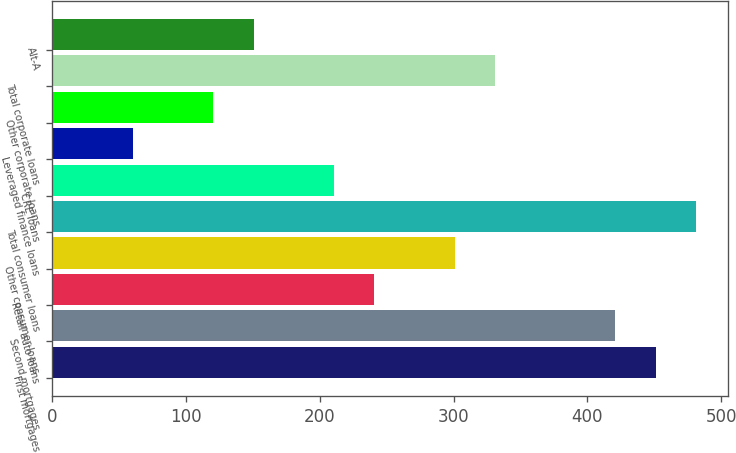<chart> <loc_0><loc_0><loc_500><loc_500><bar_chart><fcel>First mortgages<fcel>Second mortgages<fcel>Retail auto loans<fcel>Other consumer loans<fcel>Total consumer loans<fcel>CRE loans<fcel>Leveraged finance loans<fcel>Other corporate loans<fcel>Total corporate loans<fcel>Alt-A<nl><fcel>451.1<fcel>421.04<fcel>240.68<fcel>300.8<fcel>481.16<fcel>210.62<fcel>60.32<fcel>120.44<fcel>330.86<fcel>150.5<nl></chart> 